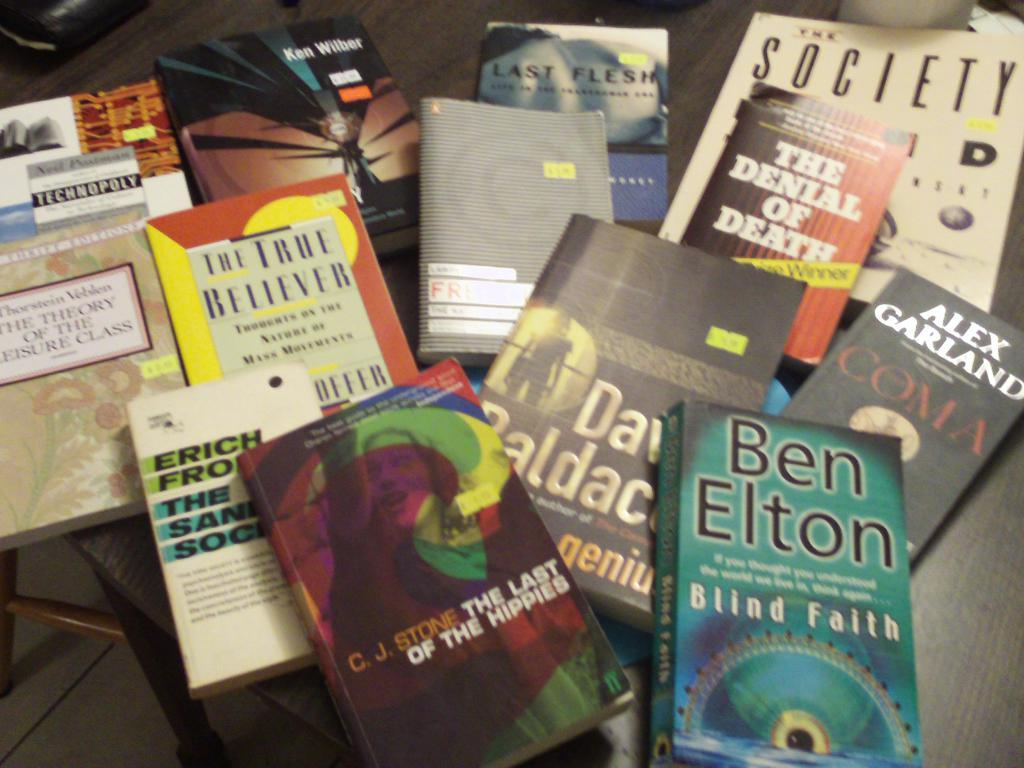<image>
Give a short and clear explanation of the subsequent image. Many books lay on a table including Blind Faith by Ben Elton. 